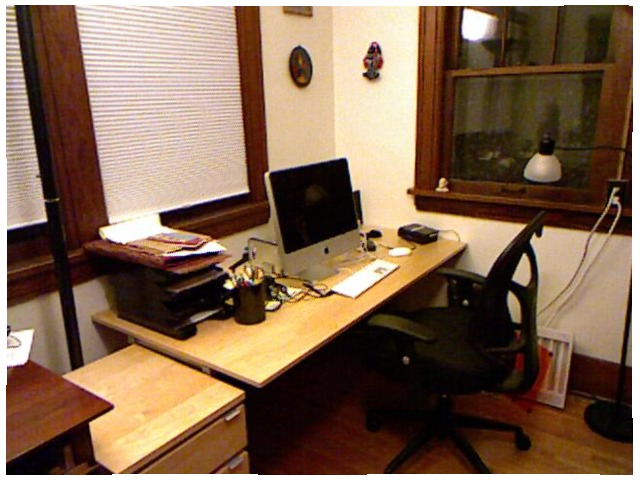<image>
Can you confirm if the chair is under the table? Yes. The chair is positioned underneath the table, with the table above it in the vertical space. Is the monitor under the table? No. The monitor is not positioned under the table. The vertical relationship between these objects is different. Where is the computer in relation to the table? Is it on the table? Yes. Looking at the image, I can see the computer is positioned on top of the table, with the table providing support. Is the chair on the table? No. The chair is not positioned on the table. They may be near each other, but the chair is not supported by or resting on top of the table. Where is the monitor in relation to the pencil holder? Is it to the right of the pencil holder? Yes. From this viewpoint, the monitor is positioned to the right side relative to the pencil holder. 